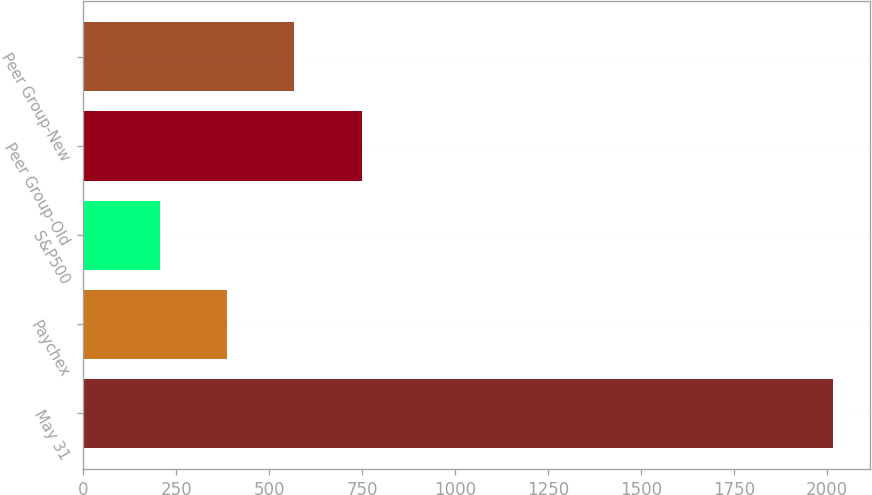Convert chart. <chart><loc_0><loc_0><loc_500><loc_500><bar_chart><fcel>May 31<fcel>Paychex<fcel>S&P500<fcel>Peer Group-Old<fcel>Peer Group-New<nl><fcel>2017<fcel>386.01<fcel>204.79<fcel>748.45<fcel>567.23<nl></chart> 